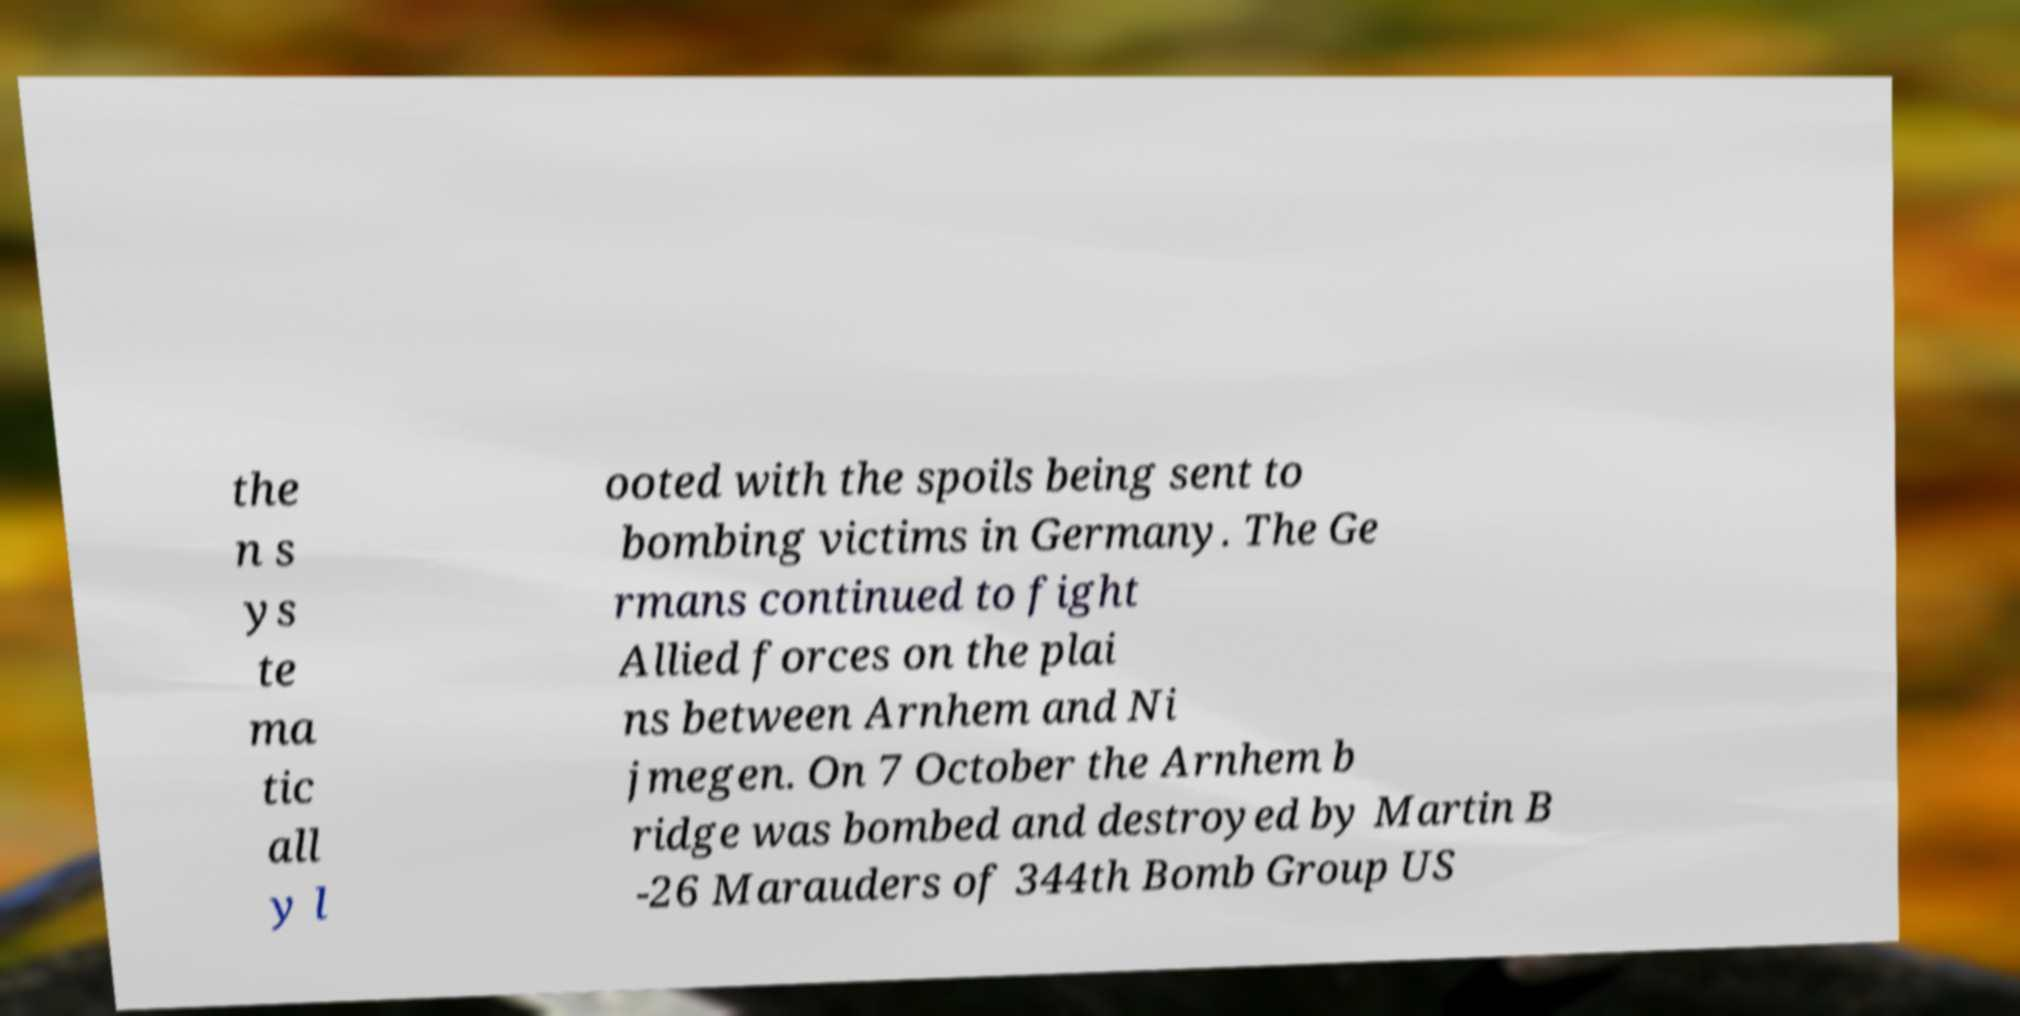What messages or text are displayed in this image? I need them in a readable, typed format. the n s ys te ma tic all y l ooted with the spoils being sent to bombing victims in Germany. The Ge rmans continued to fight Allied forces on the plai ns between Arnhem and Ni jmegen. On 7 October the Arnhem b ridge was bombed and destroyed by Martin B -26 Marauders of 344th Bomb Group US 